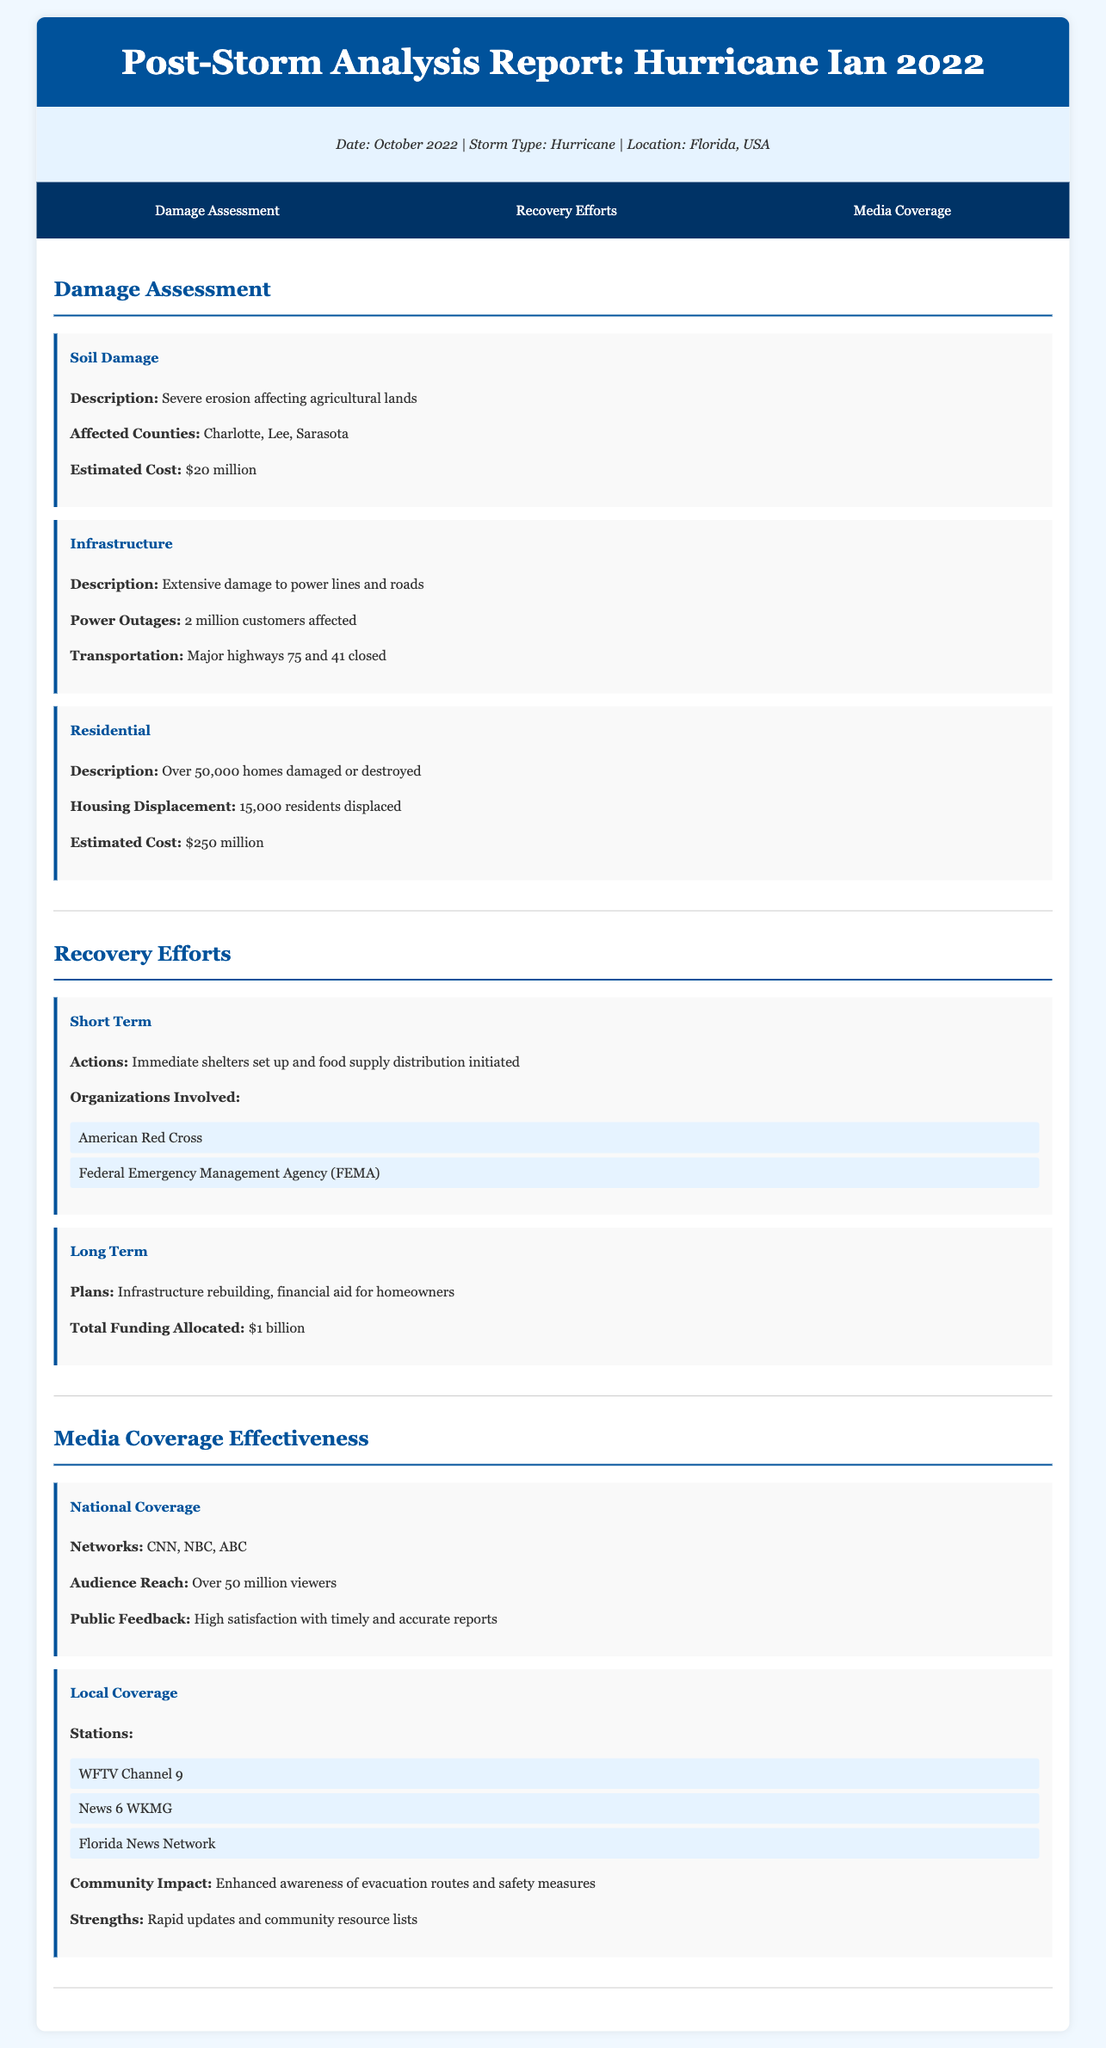What was the estimated cost of soil damage? The estimated cost of soil damage is stated in the document as the financial impact of severe erosion affecting agricultural lands.
Answer: $20 million How many homes were damaged or destroyed? The document provides specific statistics on housing damage, indicating the extent of the impact on residential areas.
Answer: Over 50,000 homes What is the total funding allocated for long-term recovery? The document mentions the financial resources that have been set aside for the recovery efforts, specifically for rebuilding and assisting homeowners.
Answer: $1 billion Which organization was involved in short-term recovery efforts? The document lists organizations that played key roles in providing immediate assistance after the storm, focusing on emergency response.
Answer: American Red Cross What is the audience reach of national media coverage? This figure indicates the extent of viewership for national news networks during the storm coverage, reflecting their effectiveness in disseminating information.
Answer: Over 50 million viewers How many residents were displaced due to the storm? This figure provides insight into the impact of the storm on community living situations following the event.
Answer: 15,000 residents What major highways were closed due to infrastructure damage? The document specifies the affected transportation routes, indicating the extent of disruptions caused by the storm.
Answer: Major highways 75 and 41 What was a key strength of local media coverage? The document highlights the effective strategies that local news stations employed to enhance community awareness and safety.
Answer: Rapid updates and community resource lists 